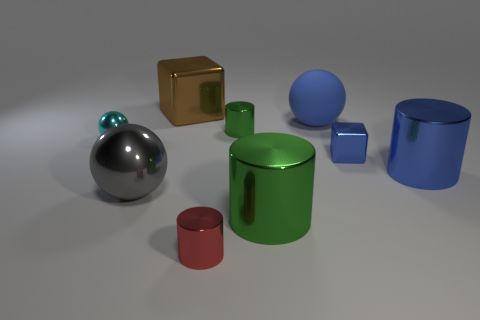What is the size of the cylinder that is the same color as the large matte thing?
Give a very brief answer. Large. There is a large shiny object that is behind the big blue rubber object; how many big metal cylinders are in front of it?
Keep it short and to the point. 2. There is another big gray thing that is the same shape as the large rubber object; what is its material?
Provide a short and direct response. Metal. Does the big thing behind the big blue ball have the same color as the tiny metallic sphere?
Your answer should be very brief. No. Do the blue cylinder and the green cylinder to the left of the large green cylinder have the same material?
Make the answer very short. Yes. There is a green object that is in front of the tiny blue metal thing; what is its shape?
Offer a terse response. Cylinder. What number of other objects are the same material as the red cylinder?
Provide a succinct answer. 7. The rubber thing is what size?
Provide a succinct answer. Large. How many other things are there of the same color as the big matte object?
Offer a terse response. 2. The big object that is both to the left of the tiny green cylinder and behind the cyan metallic ball is what color?
Ensure brevity in your answer.  Brown. 